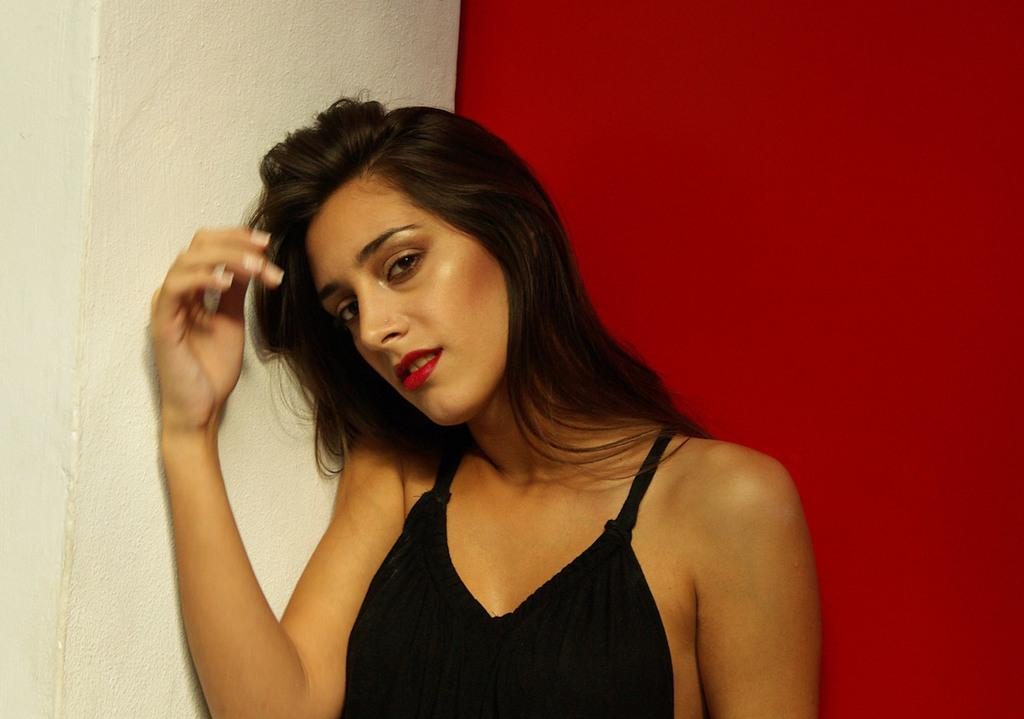What is the main subject of the image? There is a girl standing in the image. What can be seen behind the girl? There is a wall behind the girl. Can you describe the wall in the image? The wall has a red section on the right side. What type of pest can be seen crawling on the girl's shoulder in the image? There is no pest visible on the girl's shoulder in the image. How many seats are available for the band to sit on in the image? There is no band or seats present in the image. 